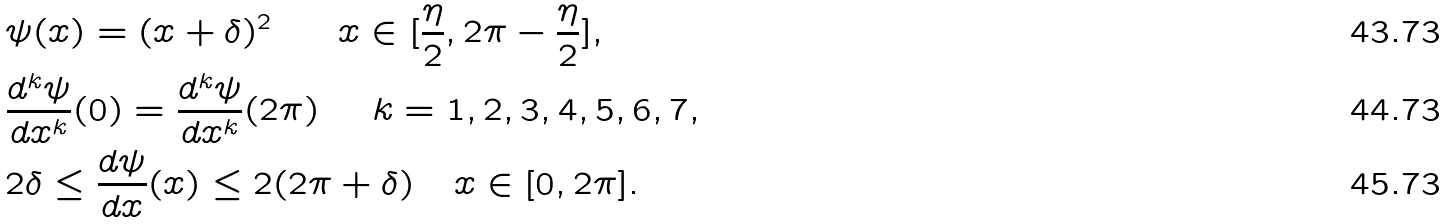Convert formula to latex. <formula><loc_0><loc_0><loc_500><loc_500>& \psi ( x ) = ( x + \delta ) ^ { 2 } \quad \ \ x \in [ \frac { \eta } { 2 } , 2 \pi - \frac { \eta } { 2 } ] , \\ & \frac { d ^ { k } \psi } { d x ^ { k } } ( 0 ) = \frac { d ^ { k } \psi } { d x ^ { k } } ( 2 \pi ) \quad \ k = 1 , 2 , 3 , 4 , 5 , 6 , 7 , \\ & 2 \delta \leq \frac { d \psi } { d x } ( x ) \leq 2 ( 2 \pi + \delta ) \quad x \in [ 0 , 2 \pi ] .</formula> 